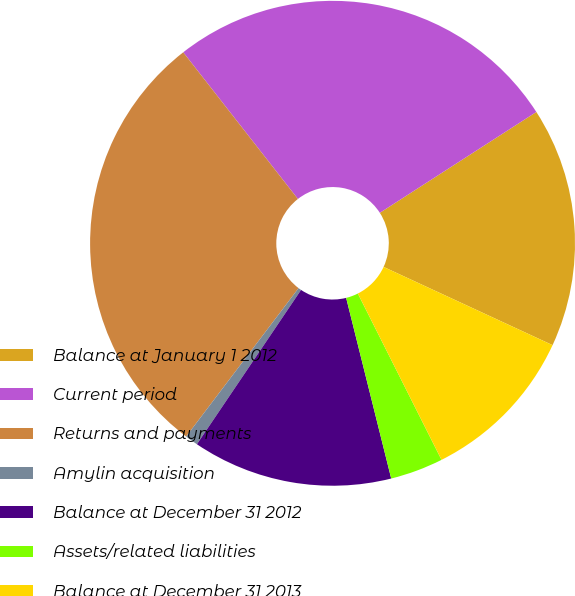Convert chart to OTSL. <chart><loc_0><loc_0><loc_500><loc_500><pie_chart><fcel>Balance at January 1 2012<fcel>Current period<fcel>Returns and payments<fcel>Amylin acquisition<fcel>Balance at December 31 2012<fcel>Assets/related liabilities<fcel>Balance at December 31 2013<nl><fcel>16.01%<fcel>26.45%<fcel>29.12%<fcel>0.87%<fcel>13.34%<fcel>3.53%<fcel>10.68%<nl></chart> 